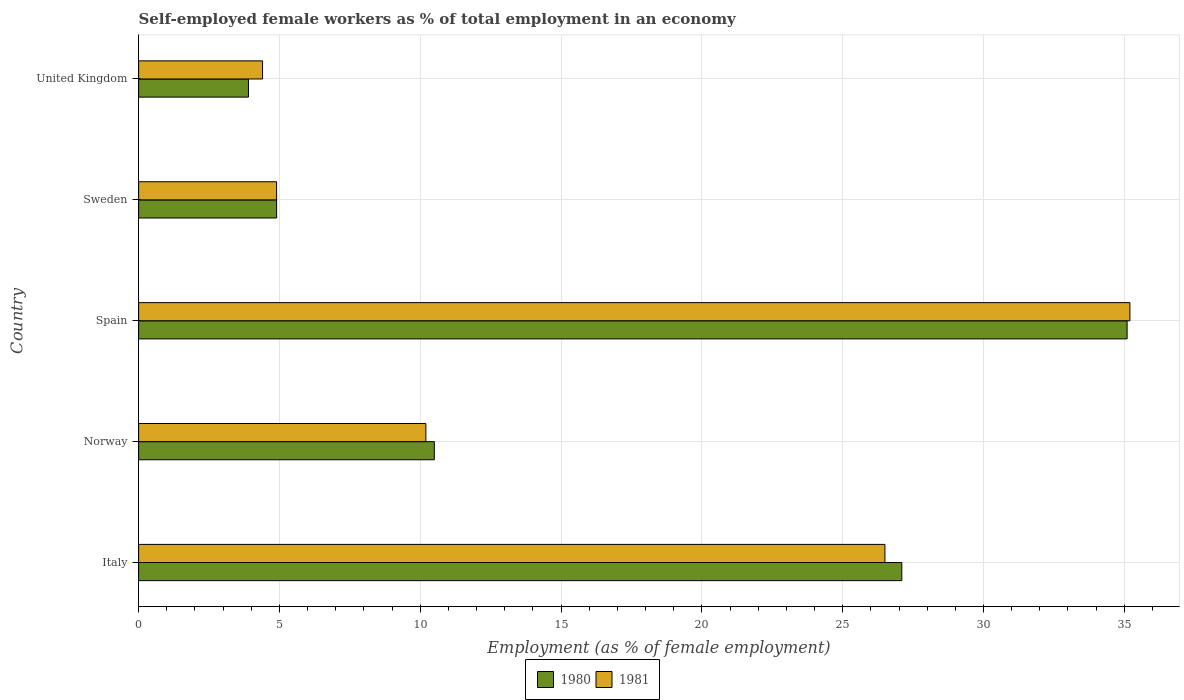How many different coloured bars are there?
Your response must be concise. 2. Are the number of bars per tick equal to the number of legend labels?
Provide a succinct answer. Yes. How many bars are there on the 3rd tick from the top?
Offer a very short reply. 2. What is the label of the 1st group of bars from the top?
Give a very brief answer. United Kingdom. In how many cases, is the number of bars for a given country not equal to the number of legend labels?
Offer a very short reply. 0. What is the percentage of self-employed female workers in 1980 in Spain?
Keep it short and to the point. 35.1. Across all countries, what is the maximum percentage of self-employed female workers in 1981?
Your answer should be very brief. 35.2. Across all countries, what is the minimum percentage of self-employed female workers in 1981?
Give a very brief answer. 4.4. In which country was the percentage of self-employed female workers in 1981 maximum?
Provide a short and direct response. Spain. In which country was the percentage of self-employed female workers in 1980 minimum?
Keep it short and to the point. United Kingdom. What is the total percentage of self-employed female workers in 1980 in the graph?
Make the answer very short. 81.5. What is the difference between the percentage of self-employed female workers in 1980 in Norway and that in United Kingdom?
Offer a very short reply. 6.6. What is the difference between the percentage of self-employed female workers in 1980 in Italy and the percentage of self-employed female workers in 1981 in United Kingdom?
Offer a terse response. 22.7. What is the average percentage of self-employed female workers in 1980 per country?
Give a very brief answer. 16.3. What is the difference between the percentage of self-employed female workers in 1981 and percentage of self-employed female workers in 1980 in Italy?
Ensure brevity in your answer.  -0.6. What is the ratio of the percentage of self-employed female workers in 1981 in Spain to that in United Kingdom?
Keep it short and to the point. 8. What is the difference between the highest and the second highest percentage of self-employed female workers in 1980?
Ensure brevity in your answer.  8. What is the difference between the highest and the lowest percentage of self-employed female workers in 1981?
Provide a short and direct response. 30.8. How many bars are there?
Offer a very short reply. 10. What is the difference between two consecutive major ticks on the X-axis?
Your answer should be compact. 5. Does the graph contain any zero values?
Make the answer very short. No. Does the graph contain grids?
Offer a terse response. Yes. How many legend labels are there?
Offer a very short reply. 2. How are the legend labels stacked?
Your answer should be very brief. Horizontal. What is the title of the graph?
Make the answer very short. Self-employed female workers as % of total employment in an economy. What is the label or title of the X-axis?
Provide a succinct answer. Employment (as % of female employment). What is the label or title of the Y-axis?
Offer a very short reply. Country. What is the Employment (as % of female employment) of 1980 in Italy?
Provide a short and direct response. 27.1. What is the Employment (as % of female employment) in 1981 in Norway?
Provide a short and direct response. 10.2. What is the Employment (as % of female employment) of 1980 in Spain?
Offer a terse response. 35.1. What is the Employment (as % of female employment) in 1981 in Spain?
Keep it short and to the point. 35.2. What is the Employment (as % of female employment) of 1980 in Sweden?
Keep it short and to the point. 4.9. What is the Employment (as % of female employment) of 1981 in Sweden?
Ensure brevity in your answer.  4.9. What is the Employment (as % of female employment) of 1980 in United Kingdom?
Provide a short and direct response. 3.9. What is the Employment (as % of female employment) of 1981 in United Kingdom?
Provide a succinct answer. 4.4. Across all countries, what is the maximum Employment (as % of female employment) in 1980?
Ensure brevity in your answer.  35.1. Across all countries, what is the maximum Employment (as % of female employment) of 1981?
Ensure brevity in your answer.  35.2. Across all countries, what is the minimum Employment (as % of female employment) of 1980?
Your answer should be compact. 3.9. Across all countries, what is the minimum Employment (as % of female employment) in 1981?
Keep it short and to the point. 4.4. What is the total Employment (as % of female employment) in 1980 in the graph?
Your answer should be compact. 81.5. What is the total Employment (as % of female employment) of 1981 in the graph?
Your answer should be very brief. 81.2. What is the difference between the Employment (as % of female employment) in 1980 in Italy and that in Spain?
Keep it short and to the point. -8. What is the difference between the Employment (as % of female employment) in 1981 in Italy and that in Spain?
Your response must be concise. -8.7. What is the difference between the Employment (as % of female employment) of 1981 in Italy and that in Sweden?
Offer a terse response. 21.6. What is the difference between the Employment (as % of female employment) in 1980 in Italy and that in United Kingdom?
Your answer should be very brief. 23.2. What is the difference between the Employment (as % of female employment) in 1981 in Italy and that in United Kingdom?
Provide a succinct answer. 22.1. What is the difference between the Employment (as % of female employment) in 1980 in Norway and that in Spain?
Your answer should be very brief. -24.6. What is the difference between the Employment (as % of female employment) in 1981 in Norway and that in Sweden?
Your response must be concise. 5.3. What is the difference between the Employment (as % of female employment) in 1980 in Norway and that in United Kingdom?
Provide a succinct answer. 6.6. What is the difference between the Employment (as % of female employment) of 1980 in Spain and that in Sweden?
Keep it short and to the point. 30.2. What is the difference between the Employment (as % of female employment) in 1981 in Spain and that in Sweden?
Offer a very short reply. 30.3. What is the difference between the Employment (as % of female employment) in 1980 in Spain and that in United Kingdom?
Make the answer very short. 31.2. What is the difference between the Employment (as % of female employment) in 1981 in Spain and that in United Kingdom?
Your answer should be compact. 30.8. What is the difference between the Employment (as % of female employment) of 1980 in Italy and the Employment (as % of female employment) of 1981 in United Kingdom?
Offer a terse response. 22.7. What is the difference between the Employment (as % of female employment) in 1980 in Norway and the Employment (as % of female employment) in 1981 in Spain?
Your response must be concise. -24.7. What is the difference between the Employment (as % of female employment) of 1980 in Spain and the Employment (as % of female employment) of 1981 in Sweden?
Provide a short and direct response. 30.2. What is the difference between the Employment (as % of female employment) of 1980 in Spain and the Employment (as % of female employment) of 1981 in United Kingdom?
Give a very brief answer. 30.7. What is the average Employment (as % of female employment) of 1980 per country?
Make the answer very short. 16.3. What is the average Employment (as % of female employment) of 1981 per country?
Your answer should be compact. 16.24. What is the difference between the Employment (as % of female employment) in 1980 and Employment (as % of female employment) in 1981 in Italy?
Make the answer very short. 0.6. What is the difference between the Employment (as % of female employment) in 1980 and Employment (as % of female employment) in 1981 in Norway?
Ensure brevity in your answer.  0.3. What is the ratio of the Employment (as % of female employment) of 1980 in Italy to that in Norway?
Your answer should be compact. 2.58. What is the ratio of the Employment (as % of female employment) in 1981 in Italy to that in Norway?
Your answer should be very brief. 2.6. What is the ratio of the Employment (as % of female employment) of 1980 in Italy to that in Spain?
Your answer should be compact. 0.77. What is the ratio of the Employment (as % of female employment) of 1981 in Italy to that in Spain?
Provide a succinct answer. 0.75. What is the ratio of the Employment (as % of female employment) in 1980 in Italy to that in Sweden?
Give a very brief answer. 5.53. What is the ratio of the Employment (as % of female employment) of 1981 in Italy to that in Sweden?
Your response must be concise. 5.41. What is the ratio of the Employment (as % of female employment) in 1980 in Italy to that in United Kingdom?
Offer a terse response. 6.95. What is the ratio of the Employment (as % of female employment) of 1981 in Italy to that in United Kingdom?
Provide a short and direct response. 6.02. What is the ratio of the Employment (as % of female employment) in 1980 in Norway to that in Spain?
Offer a terse response. 0.3. What is the ratio of the Employment (as % of female employment) in 1981 in Norway to that in Spain?
Provide a succinct answer. 0.29. What is the ratio of the Employment (as % of female employment) in 1980 in Norway to that in Sweden?
Give a very brief answer. 2.14. What is the ratio of the Employment (as % of female employment) of 1981 in Norway to that in Sweden?
Keep it short and to the point. 2.08. What is the ratio of the Employment (as % of female employment) of 1980 in Norway to that in United Kingdom?
Provide a short and direct response. 2.69. What is the ratio of the Employment (as % of female employment) of 1981 in Norway to that in United Kingdom?
Provide a short and direct response. 2.32. What is the ratio of the Employment (as % of female employment) of 1980 in Spain to that in Sweden?
Your response must be concise. 7.16. What is the ratio of the Employment (as % of female employment) in 1981 in Spain to that in Sweden?
Make the answer very short. 7.18. What is the ratio of the Employment (as % of female employment) of 1980 in Sweden to that in United Kingdom?
Your answer should be very brief. 1.26. What is the ratio of the Employment (as % of female employment) in 1981 in Sweden to that in United Kingdom?
Your answer should be very brief. 1.11. What is the difference between the highest and the second highest Employment (as % of female employment) of 1981?
Offer a very short reply. 8.7. What is the difference between the highest and the lowest Employment (as % of female employment) of 1980?
Your answer should be very brief. 31.2. What is the difference between the highest and the lowest Employment (as % of female employment) in 1981?
Provide a short and direct response. 30.8. 